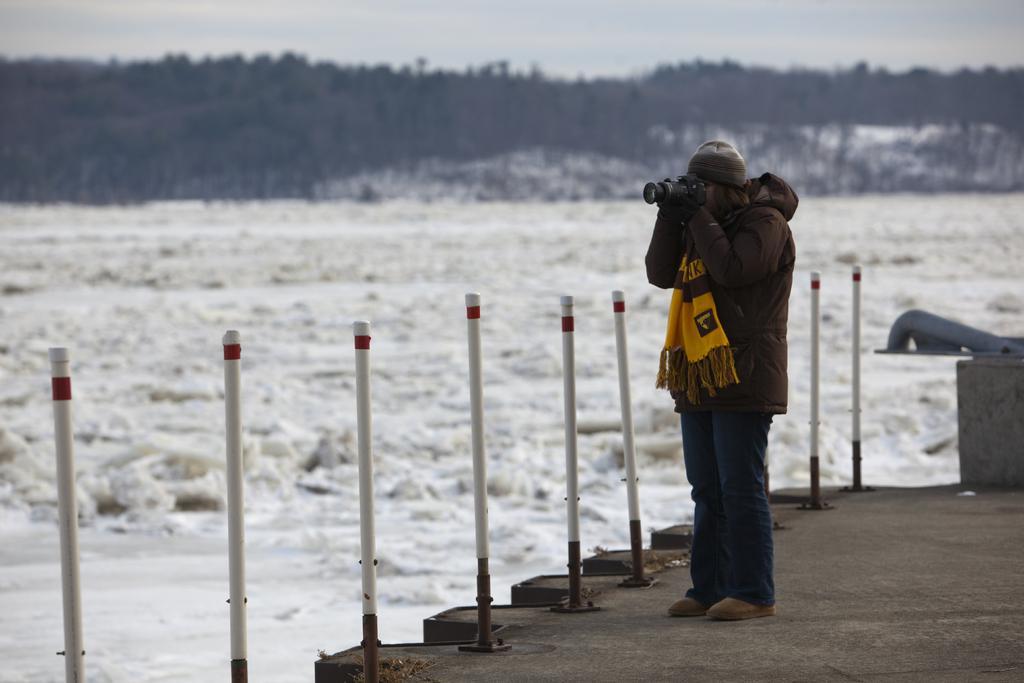Could you give a brief overview of what you see in this image? To the right side of the image there is a person wearing a jacket and holding a camera in his hand. In the background of the image there are trees. There is water. There are safety poles. At the bottom of the image there is floor. At the top of the image there is sky. 